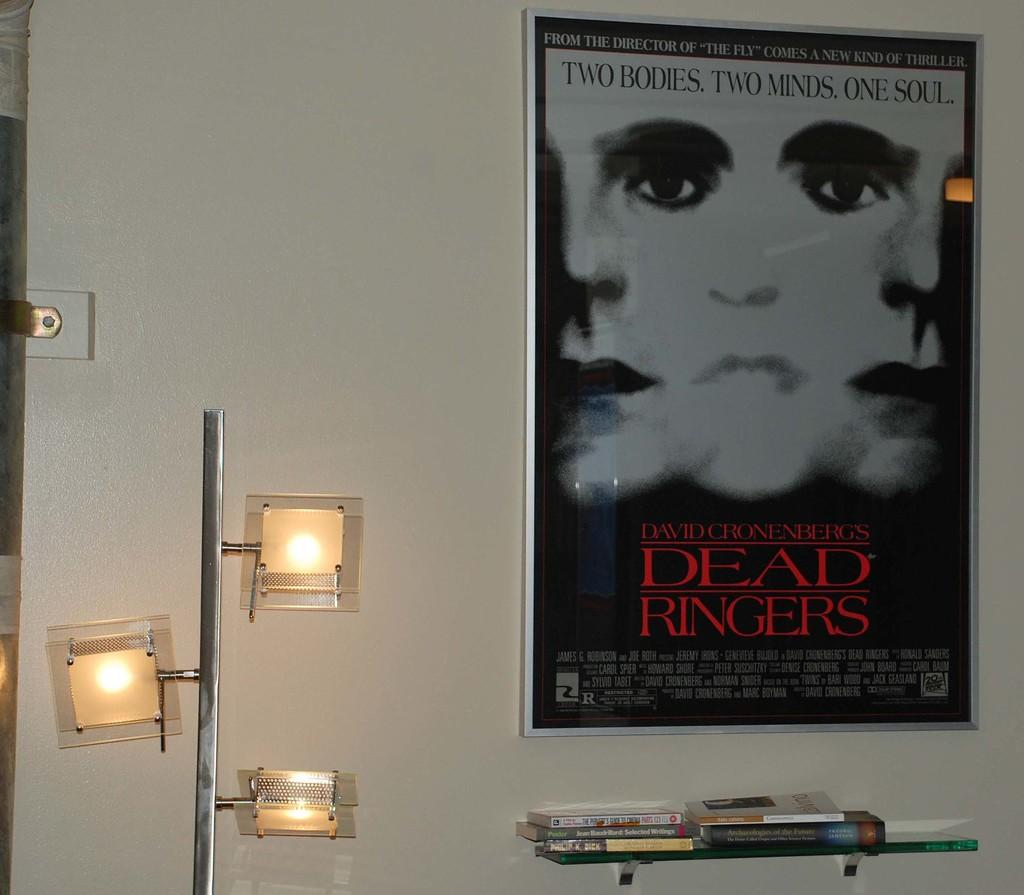<image>
Describe the image concisely. Movie Poster on a Wall that says David Cronenberg's Dead Ringers. 